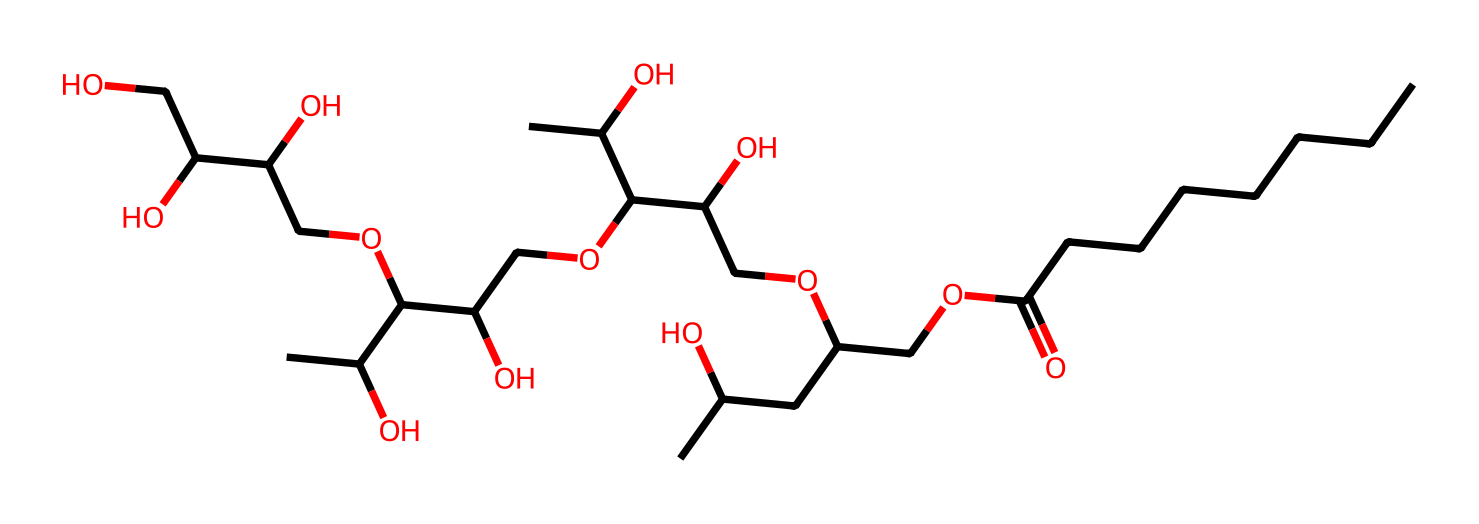How many carbon atoms are in polysorbate 80? To find the number of carbon atoms, we count the 'C' symbols present in the SMILES representation. There are 20 'C' atoms present which constitute the carbon backbone of this compound.
Answer: 20 What functional groups are present in polysorbate 80? In the given SMILES, we can identify carboxylic acid (from -COOH), ester (from -O- linking parts), and hydroxyl (-OH) groups. This means polysorbate 80 has primary functional groups such as –COOH, –O–, and –OH.
Answer: carboxylic acid, ester, hydroxyl What is the molecular weight of polysorbate 80? The molecular weight calculation can be derived from the number of each type of atom represented in the SMILES. Counting along and converting each type (C, H, O) into its weight: Carbon (12.01), Hydrogen (1.008), Oxygen (16.00), we find the total molecular weight is approximately 1310.
Answer: 1310 What type of surfactant is polysorbate 80? Polysorbate 80 is a non-ionic surfactant due to the lack of electric charge on the surfactant molecule. Analyzing the structure's features, there's no negative or positive group that would classify it otherwise.
Answer: non-ionic What is the primary application of polysorbate 80 in processed foods? The primary application of polysorbate 80 is as an emulsifier, allowing for the mixing of oil and water components effectively. Understanding the structure's properties helps us link it to its functionality in stabilizing emulsions.
Answer: emulsifier What kind of interactions does polysorbate 80 promote in emulsions? Polysorbate 80 promotes hydrophilic-lipophilic interactions, which allows oil droplets to remain dispersed in water. This characteristic can also be seen in its hydrophobic chains and hydrophilic head as shown in the SMILES structure.
Answer: hydrophilic-lipophilic interactions What aspect of polysorbate 80's structure contributes to its hydrophilicity? The hydrophilicity of polysorbate 80 derives from the presence of multiple hydroxyl (-OH) groups as evident in the structure. The hydroxyl groups allow the molecule to interact favorably with water, enhancing solubility.
Answer: hydroxyl groups 